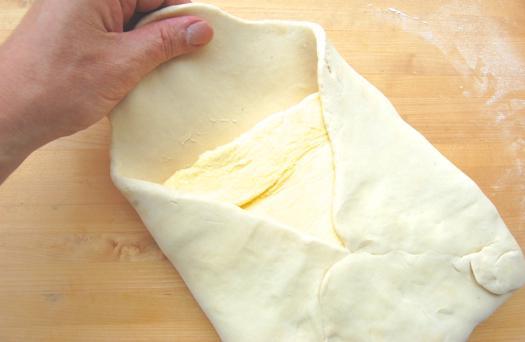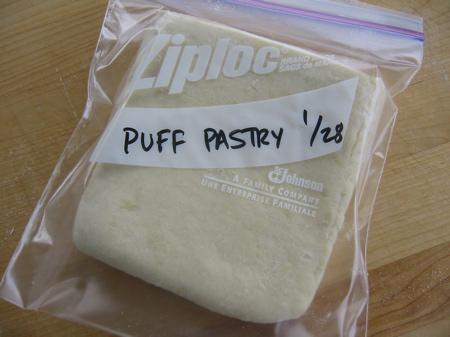The first image is the image on the left, the second image is the image on the right. Given the left and right images, does the statement "There is dough in plastic." hold true? Answer yes or no. Yes. The first image is the image on the left, the second image is the image on the right. For the images shown, is this caption "There are two folded pieces of dough with one in plastic." true? Answer yes or no. Yes. 